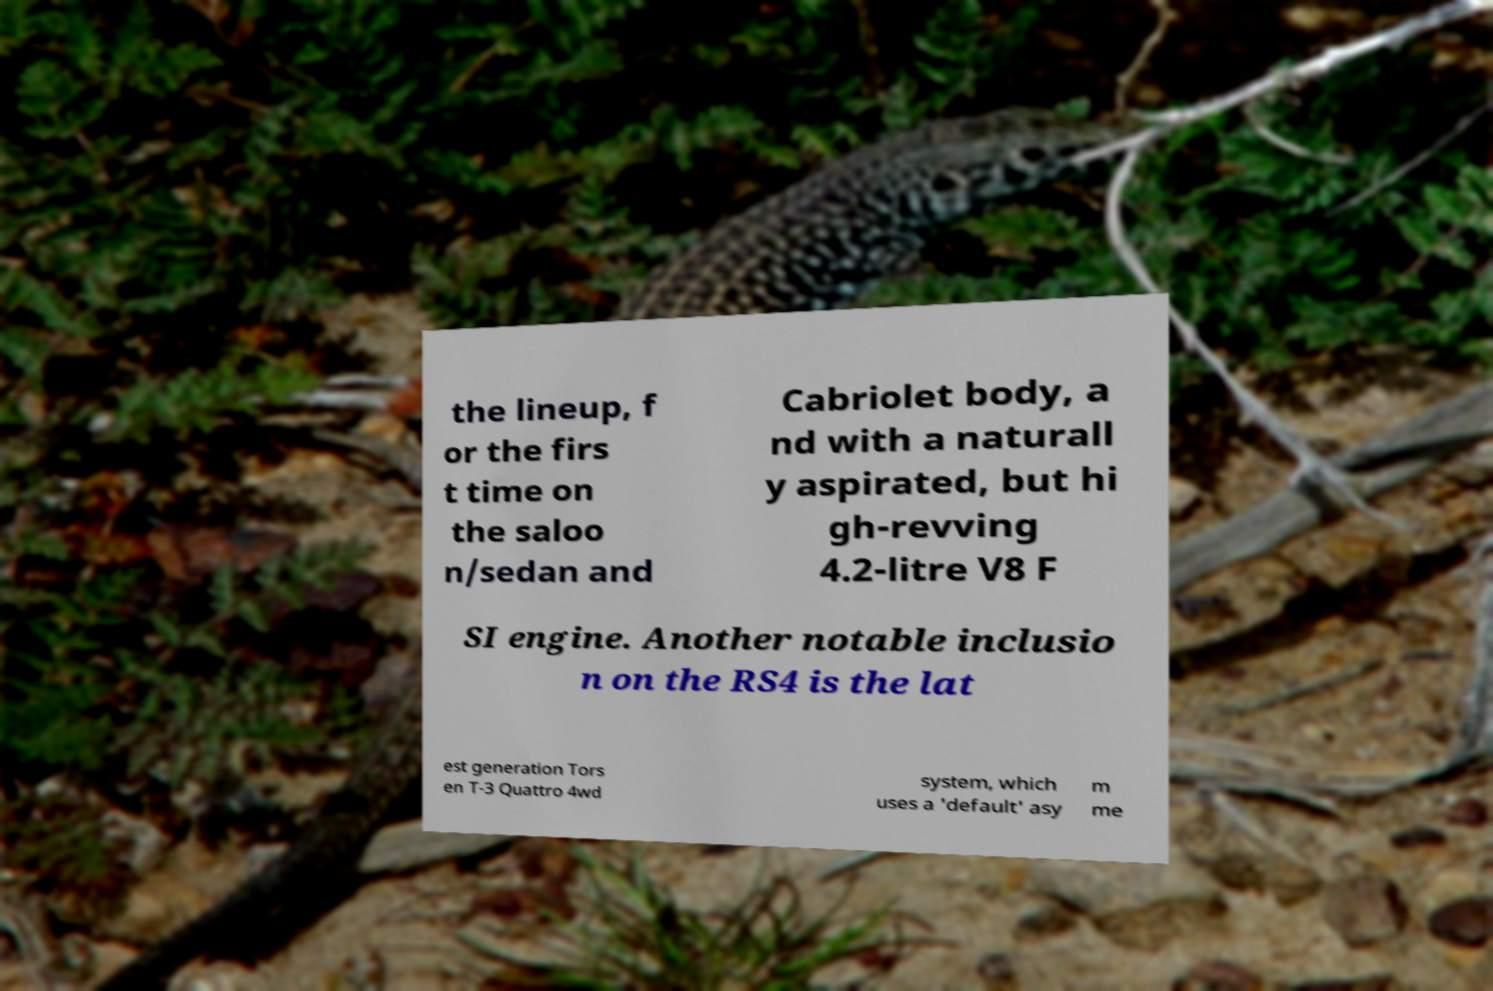What messages or text are displayed in this image? I need them in a readable, typed format. the lineup, f or the firs t time on the saloo n/sedan and Cabriolet body, a nd with a naturall y aspirated, but hi gh-revving 4.2-litre V8 F SI engine. Another notable inclusio n on the RS4 is the lat est generation Tors en T-3 Quattro 4wd system, which uses a 'default' asy m me 